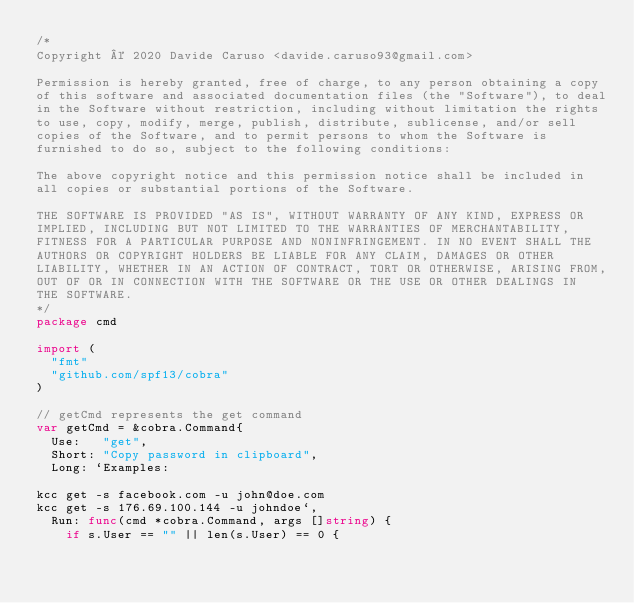Convert code to text. <code><loc_0><loc_0><loc_500><loc_500><_Go_>/*
Copyright © 2020 Davide Caruso <davide.caruso93@gmail.com>

Permission is hereby granted, free of charge, to any person obtaining a copy
of this software and associated documentation files (the "Software"), to deal
in the Software without restriction, including without limitation the rights
to use, copy, modify, merge, publish, distribute, sublicense, and/or sell
copies of the Software, and to permit persons to whom the Software is
furnished to do so, subject to the following conditions:

The above copyright notice and this permission notice shall be included in
all copies or substantial portions of the Software.

THE SOFTWARE IS PROVIDED "AS IS", WITHOUT WARRANTY OF ANY KIND, EXPRESS OR
IMPLIED, INCLUDING BUT NOT LIMITED TO THE WARRANTIES OF MERCHANTABILITY,
FITNESS FOR A PARTICULAR PURPOSE AND NONINFRINGEMENT. IN NO EVENT SHALL THE
AUTHORS OR COPYRIGHT HOLDERS BE LIABLE FOR ANY CLAIM, DAMAGES OR OTHER
LIABILITY, WHETHER IN AN ACTION OF CONTRACT, TORT OR OTHERWISE, ARISING FROM,
OUT OF OR IN CONNECTION WITH THE SOFTWARE OR THE USE OR OTHER DEALINGS IN
THE SOFTWARE.
*/
package cmd

import (
	"fmt"
	"github.com/spf13/cobra"
)

// getCmd represents the get command
var getCmd = &cobra.Command{
	Use:   "get",
	Short: "Copy password in clipboard",
	Long: `Examples:

kcc get -s facebook.com -u john@doe.com
kcc get -s 176.69.100.144 -u johndoe`,
	Run: func(cmd *cobra.Command, args []string) {
		if s.User == "" || len(s.User) == 0 {</code> 